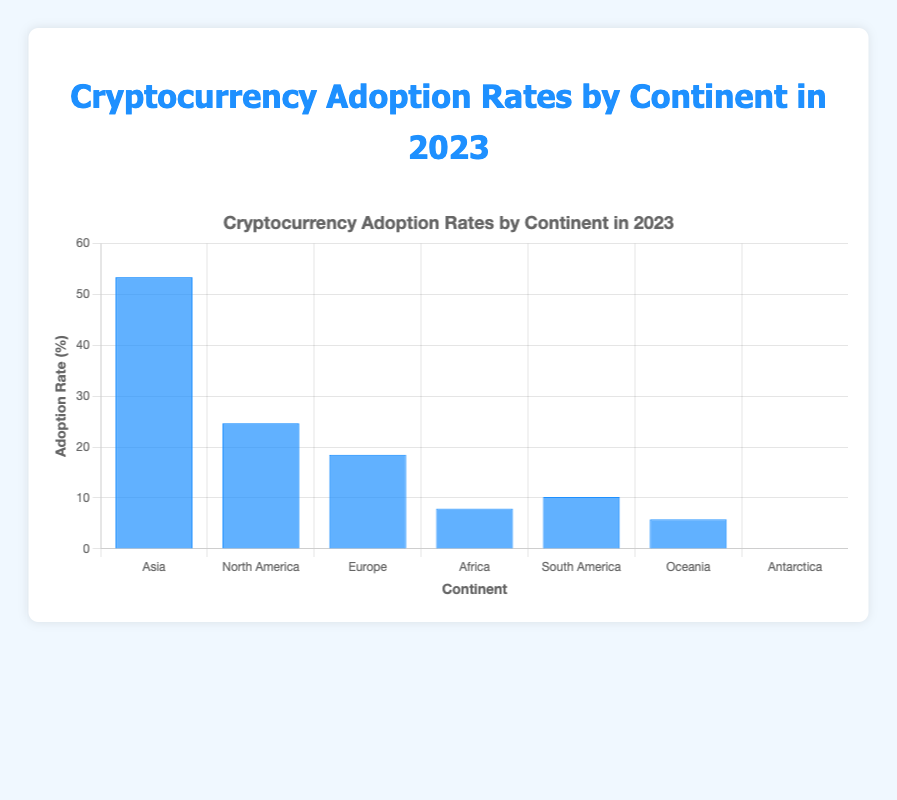What's the continent with the highest cryptocurrency adoption rate in 2023? By visually checking the bar heights, Asia's bar is the tallest, indicating it has the highest adoption rate.
Answer: Asia Which continent has a higher adoption rate: Europe or North America? By comparing the heights of the bars for Europe and North America, North America's bar is higher than Europe's.
Answer: North America What is the difference in adoption rate between South America and Africa? Subtract Africa's adoption rate (7.9%) from South America's adoption rate (10.2%): 10.2% - 7.9% = 2.3%.
Answer: 2.3% Is the adoption rate in Oceania higher than in Antarctica? By comparing the bar heights, Oceania's bar is significantly higher than Antarctica's.
Answer: Yes What's the combined adoption rate percentage for Asia and North America? Add Asia's adoption rate (53.4%) to North America's (24.7%): 53.4% + 24.7% = 78.1%.
Answer: 78.1% Among the continents listed, which has the lowest cryptocurrency adoption rate? By visually comparing the bar heights, Antarctica has the shortest bar, indicating the lowest adoption rate.
Answer: Antarctica What's the approximate average adoption rate among all continents? Sum all adoption rates and divide by the number of continents: (53.4 + 24.7 + 18.5 + 7.9 + 10.2 + 5.8 + 0.1) / 7 ≈ 17.23%.
Answer: 17.2% How many continents have an adoption rate below 10%? By visually checking, Africa, South America, Oceania, and Antarctica have adoption rates below 10%. This counts to 4.
Answer: 4 